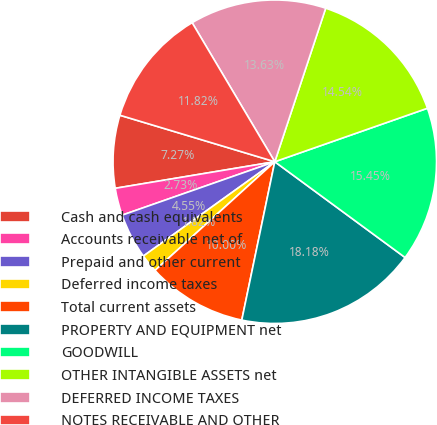<chart> <loc_0><loc_0><loc_500><loc_500><pie_chart><fcel>Cash and cash equivalents<fcel>Accounts receivable net of<fcel>Prepaid and other current<fcel>Deferred income taxes<fcel>Total current assets<fcel>PROPERTY AND EQUIPMENT net<fcel>GOODWILL<fcel>OTHER INTANGIBLE ASSETS net<fcel>DEFERRED INCOME TAXES<fcel>NOTES RECEIVABLE AND OTHER<nl><fcel>7.27%<fcel>2.73%<fcel>4.55%<fcel>1.82%<fcel>10.0%<fcel>18.18%<fcel>15.45%<fcel>14.54%<fcel>13.63%<fcel>11.82%<nl></chart> 